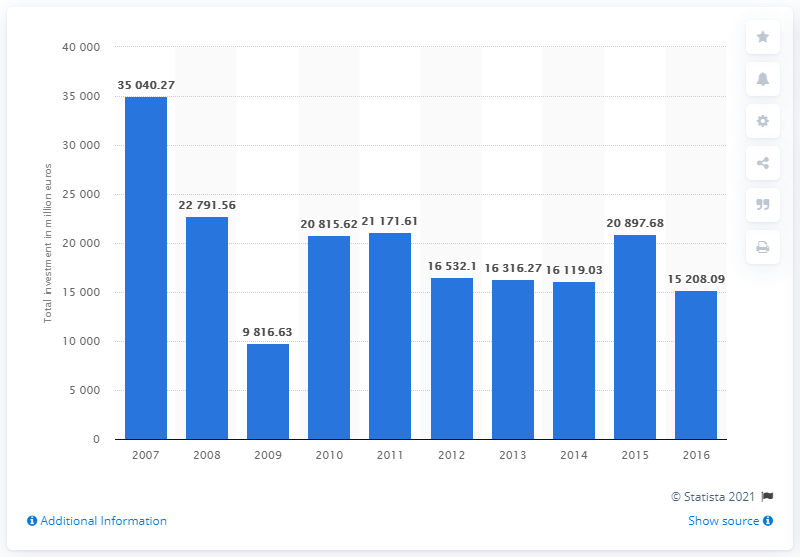Mention a couple of crucial points in this snapshot. In 2007, the total value of private equity investments was approximately 35,040.27. Private equity investments in 2016 were valued at 15,208.09. 